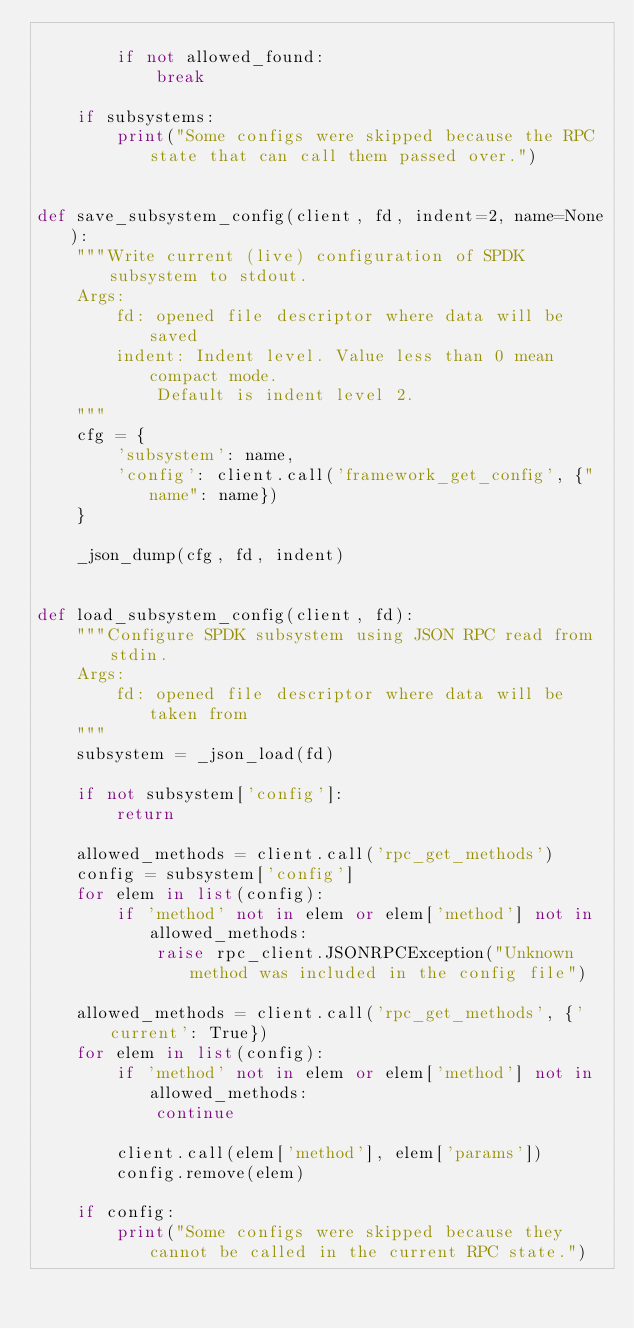Convert code to text. <code><loc_0><loc_0><loc_500><loc_500><_Python_>
        if not allowed_found:
            break

    if subsystems:
        print("Some configs were skipped because the RPC state that can call them passed over.")


def save_subsystem_config(client, fd, indent=2, name=None):
    """Write current (live) configuration of SPDK subsystem to stdout.
    Args:
        fd: opened file descriptor where data will be saved
        indent: Indent level. Value less than 0 mean compact mode.
            Default is indent level 2.
    """
    cfg = {
        'subsystem': name,
        'config': client.call('framework_get_config', {"name": name})
    }

    _json_dump(cfg, fd, indent)


def load_subsystem_config(client, fd):
    """Configure SPDK subsystem using JSON RPC read from stdin.
    Args:
        fd: opened file descriptor where data will be taken from
    """
    subsystem = _json_load(fd)

    if not subsystem['config']:
        return

    allowed_methods = client.call('rpc_get_methods')
    config = subsystem['config']
    for elem in list(config):
        if 'method' not in elem or elem['method'] not in allowed_methods:
            raise rpc_client.JSONRPCException("Unknown method was included in the config file")

    allowed_methods = client.call('rpc_get_methods', {'current': True})
    for elem in list(config):
        if 'method' not in elem or elem['method'] not in allowed_methods:
            continue

        client.call(elem['method'], elem['params'])
        config.remove(elem)

    if config:
        print("Some configs were skipped because they cannot be called in the current RPC state.")
</code> 